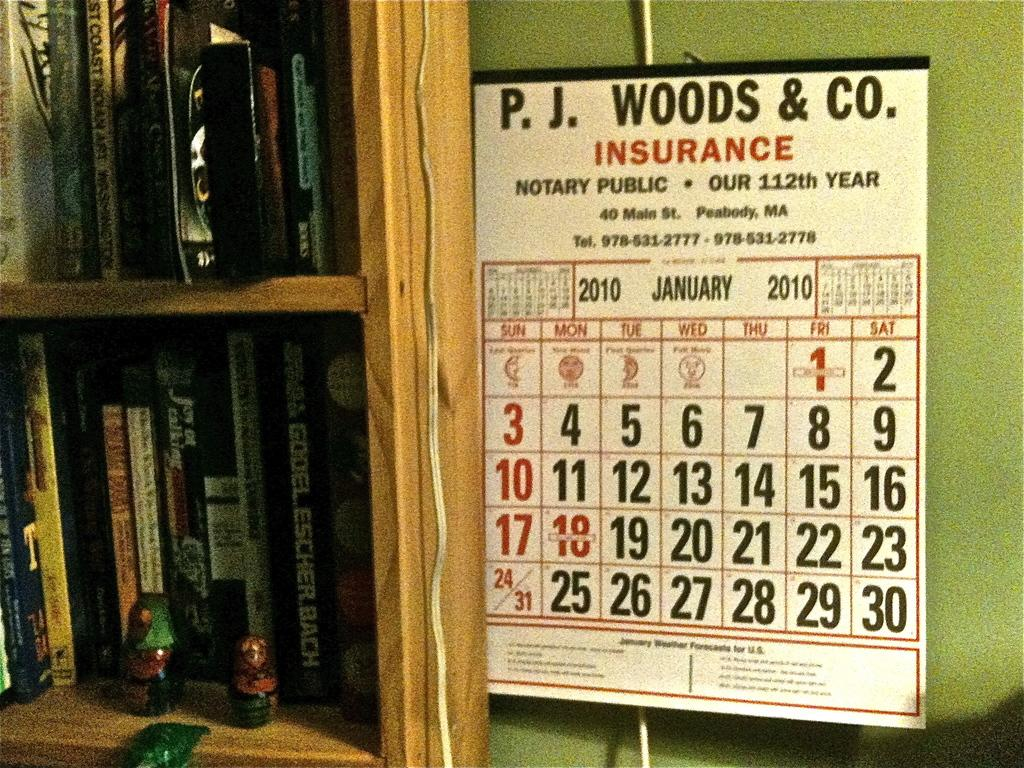What type of items can be seen in the image? There are books and toys in the image. How are the books and toys organized in the image? The books and toys are in racks. What other item can be seen in the image? There is a calendar in the image. What color is the wall behind the calendar? The wall behind the calendar is green. What type of coach is visible in the image? There is no coach present in the image. What type of haircut is the person in the image getting? There is no person getting a haircut in the image. 